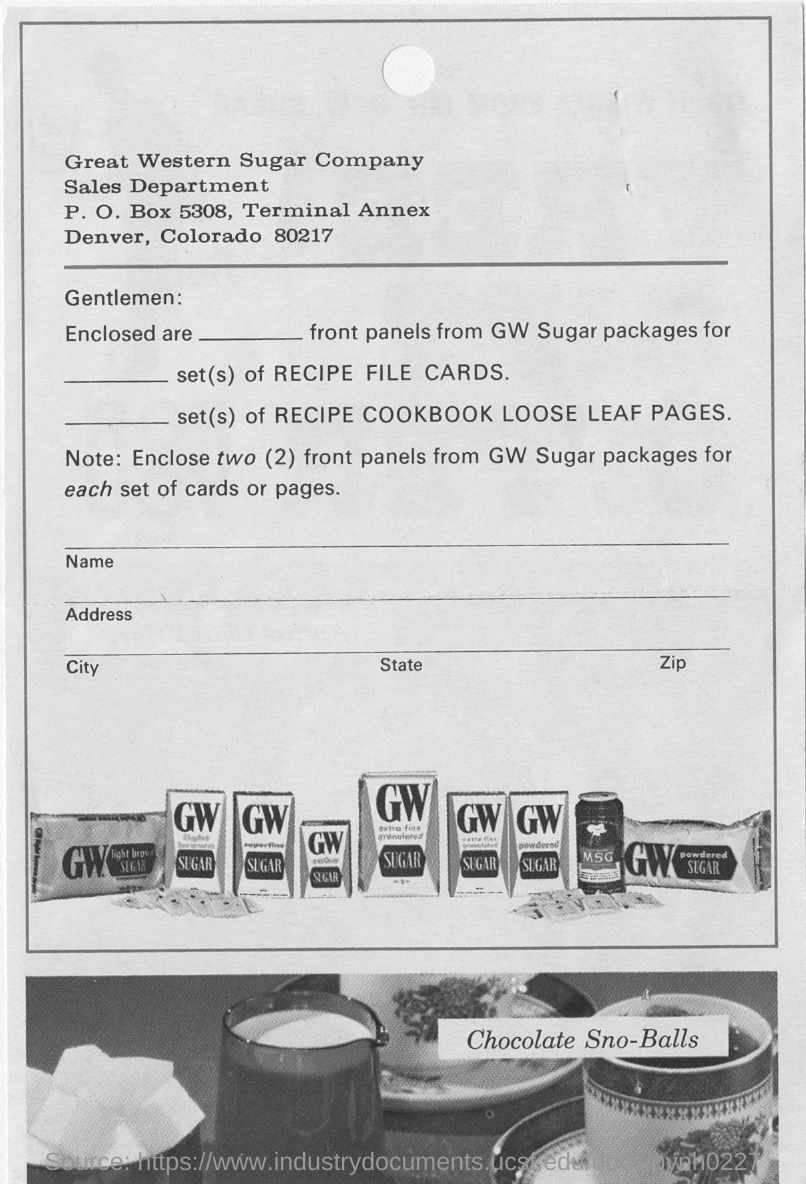What is  written on the bottom picture?
Ensure brevity in your answer.  Chocolate Sno-Balls. What are the two letters in Bold on those packets in the first picture?
Ensure brevity in your answer.  GW. 